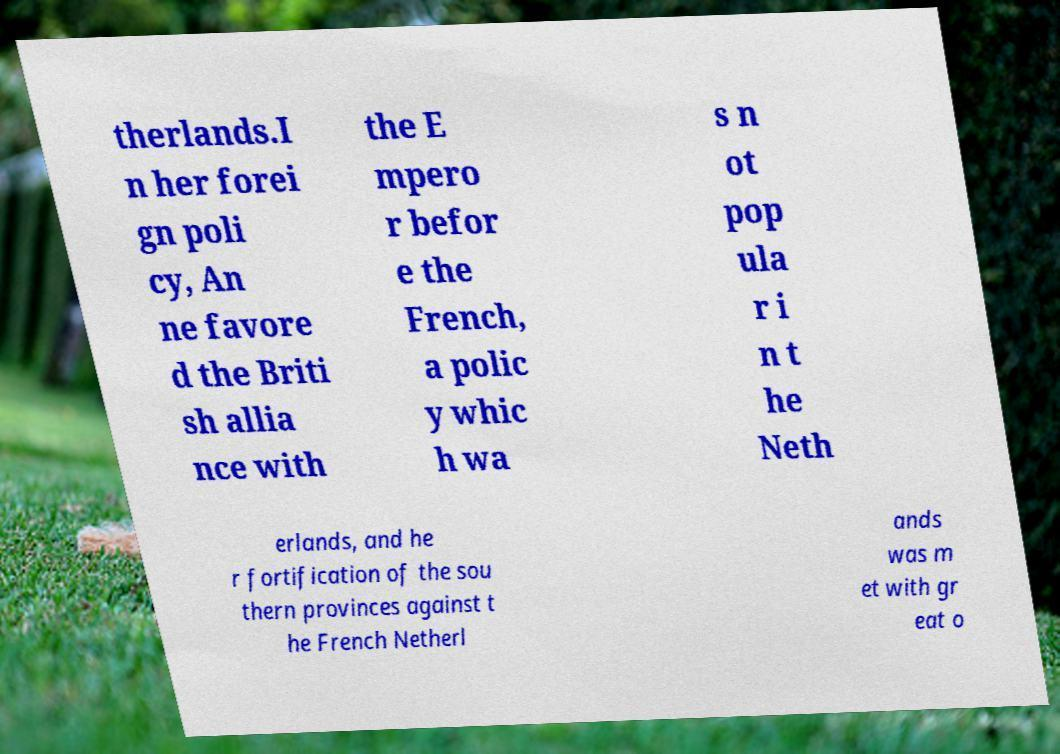Can you read and provide the text displayed in the image?This photo seems to have some interesting text. Can you extract and type it out for me? therlands.I n her forei gn poli cy, An ne favore d the Briti sh allia nce with the E mpero r befor e the French, a polic y whic h wa s n ot pop ula r i n t he Neth erlands, and he r fortification of the sou thern provinces against t he French Netherl ands was m et with gr eat o 